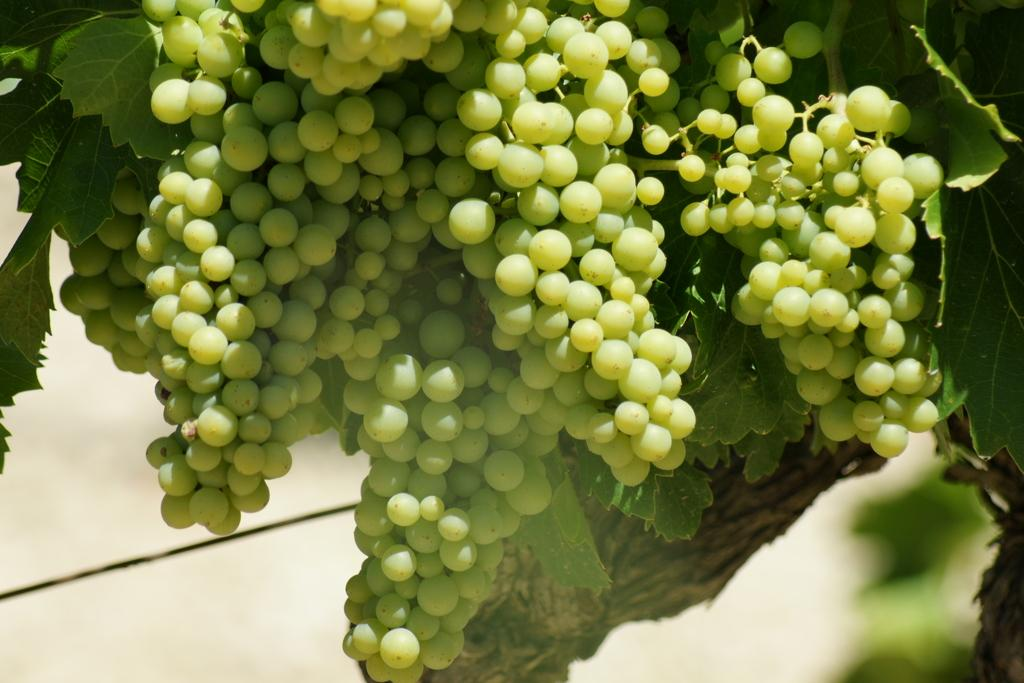What type of tree is present in the image? There is a grape tree in the image. What type of farm can be seen in the background of the image? There is no farm present in the image; it only features a grape tree. What color is the thread used to hang the reward in the image? There is no thread or reward present in the image; it only features a grape tree. 